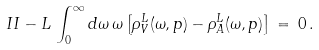<formula> <loc_0><loc_0><loc_500><loc_500>I I - L \, \int _ { 0 } ^ { \infty } d \omega \, \omega \left [ \rho _ { V } ^ { L } ( \omega , { p } ) - \rho _ { A } ^ { L } ( \omega , { p } ) \right ] \, = \, 0 \, .</formula> 